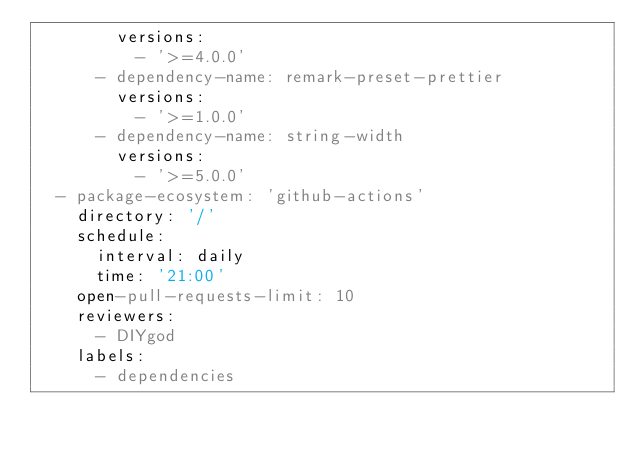<code> <loc_0><loc_0><loc_500><loc_500><_YAML_>        versions:
          - '>=4.0.0'
      - dependency-name: remark-preset-prettier
        versions:
          - '>=1.0.0'
      - dependency-name: string-width
        versions:
          - '>=5.0.0'
  - package-ecosystem: 'github-actions'
    directory: '/'
    schedule:
      interval: daily
      time: '21:00'
    open-pull-requests-limit: 10
    reviewers:
      - DIYgod
    labels:
      - dependencies
</code> 